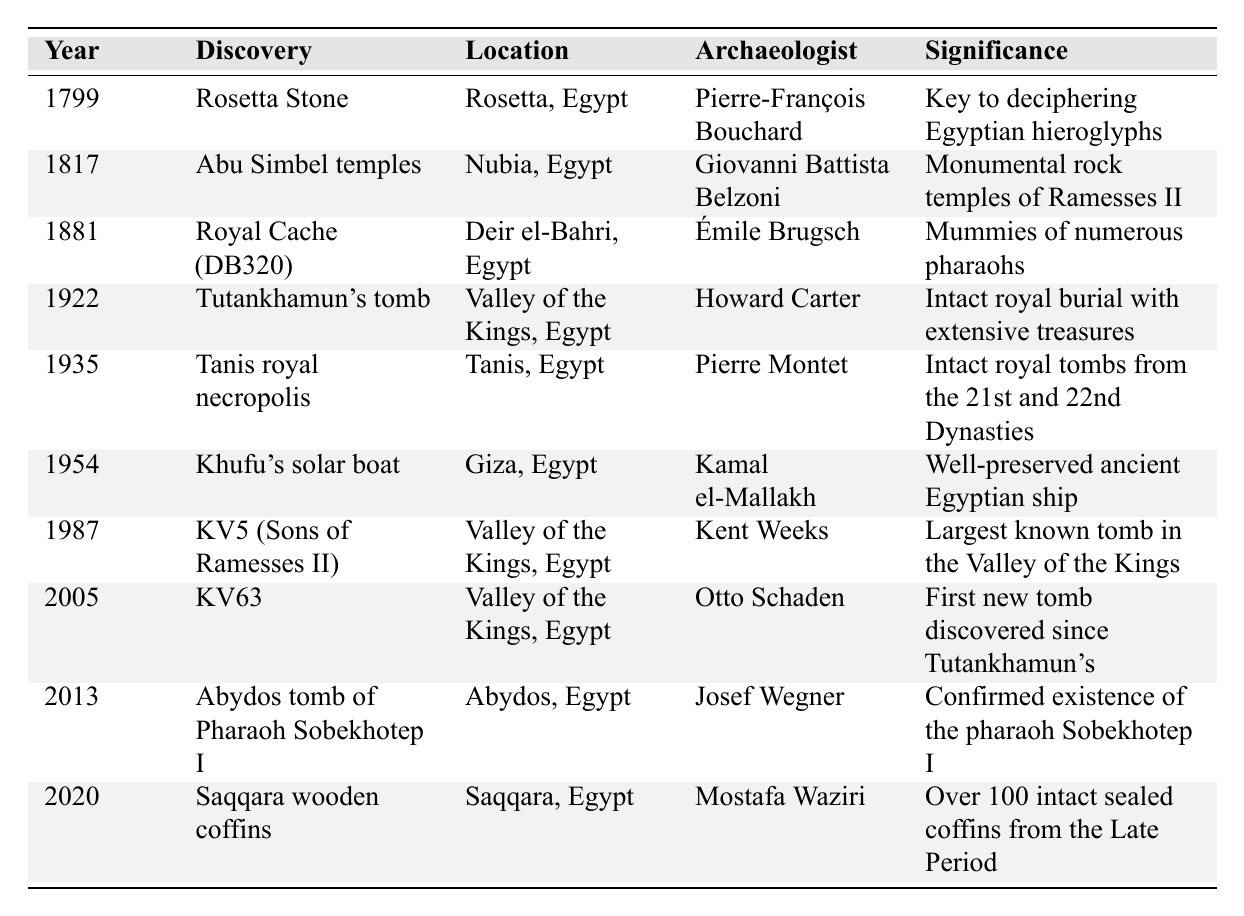What year was the Rosetta Stone discovered? The table explicitly lists the year of the Rosetta Stone discovery as 1799 under the "Year" column next to its respective "Discovery."
Answer: 1799 Who was the archaeologist that discovered Tutankhamun's tomb? The table indicates that Howard Carter is the archaeologist associated with the discovery of Tutankhamun's tomb, as stated in the "Archaeologist" column.
Answer: Howard Carter Which discovery took place in 1881? According to the table, the "Royal Cache (DB320)" is the discovery that occurred in 1881, as found in the "Year" column.
Answer: Royal Cache (DB320) In which location was the Saqqara wooden coffins discovery made? By examining the "Location" column in the table, we see that the Saqqara wooden coffins were discovered in Saqqara, Egypt.
Answer: Saqqara, Egypt How many years are there between the discovery of the Khufu's solar boat and the KV5 tomb? The discovery of Khufu's solar boat occurred in 1954, and KV5 was discovered in 1987. The difference in years is 1987 - 1954 = 33 years.
Answer: 33 years Was the discovery of KV63 significant due to being the first new tomb discovered since Tutankhamun's? Yes, the table indicates that KV63's significance includes it being the first new tomb discovered since Tutankhamun's tomb, as mentioned in the "Significance" column.
Answer: Yes How many discoveries were made in the Valley of the Kings? By checking the "Location" column for "Valley of the Kings," we count 4 discoveries: Tutankhamun's tomb, KV5, KV63, and the KV5 (Sons of Ramesses II).
Answer: 4 discoveries What is the significance of the discovery made in 2005? The table explains that the significance of the KV63 discovery, made in 2005, is that it was the first new tomb discovered since Tutankhamun's, found under the "Significance" column.
Answer: First new tomb since Tutankhamun's Which archaeologist conducted the discovery of the Abu Simbel temples? The table lists Giovanni Battista Belzoni as the archaeologist responsible for the Abu Simbel temples discovery according to the "Archaeologist" column.
Answer: Giovanni Battista Belzoni If we combine the discoveries in the years 1922 and 1954, what notable significance do they share? Both discoveries, Tutankhamun's tomb (1922) and Khufu's solar boat (1954), are significant as they relate to royal burial practices in ancient Egypt, as mentioned in their significance descriptions.
Answer: Related to royal burial practices Give the average year of discoveries listed in the table. There are 10 discoveries in the table, with years summing to 1799 + 1817 + 1881 + 1922 + 1935 + 1954 + 1987 + 2005 + 2013 + 2020 = 18,013. The average is 18,013 / 10 = 1,801.3, which we can round to 1801.
Answer: 1801 